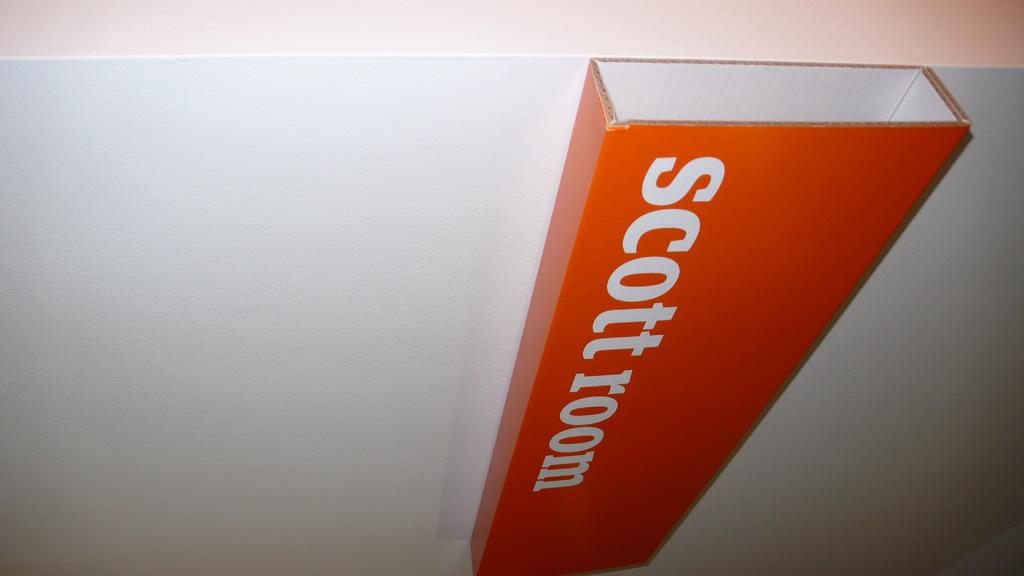<image>
Present a compact description of the photo's key features. An orange sign on a white wall that says scott room 